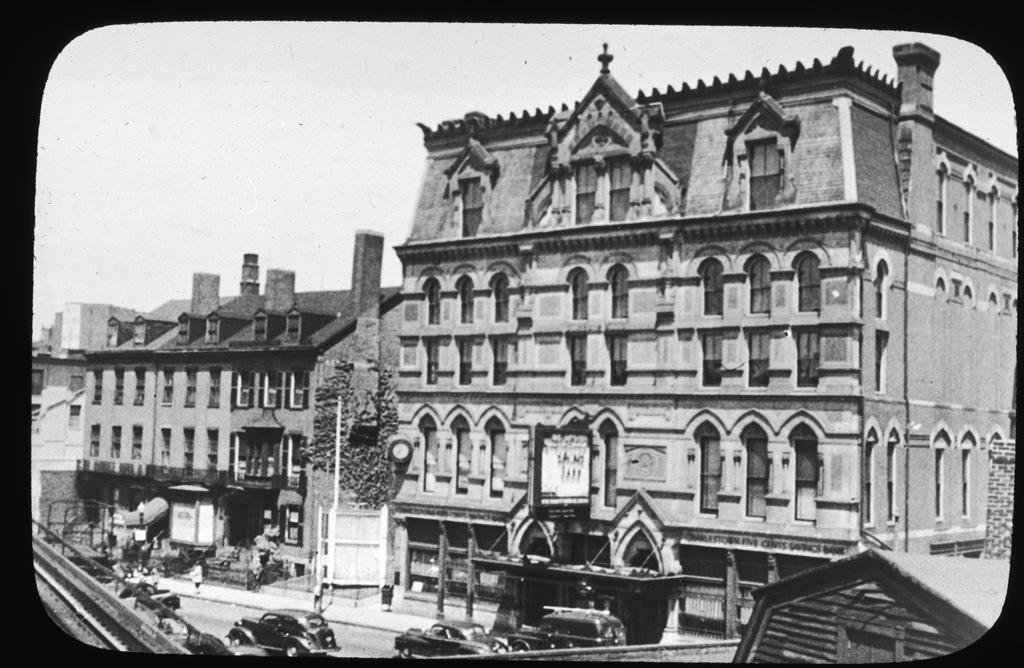What type of structures can be seen in the image? There are buildings with windows in the image. What is present on the ground in the image? There is a road in the image. What is moving on the road? There are vehicles on the road. What is the color scheme of the image? The image is in black and white. What can be seen in the background of the image? There is sky visible in the background of the image. Can you tell me how many daughters are playing in the yard in the image? There is no daughter or yard present in the image. What type of liquid is being spilled on the road in the image? There is no liquid being spilled on the road in the image. 